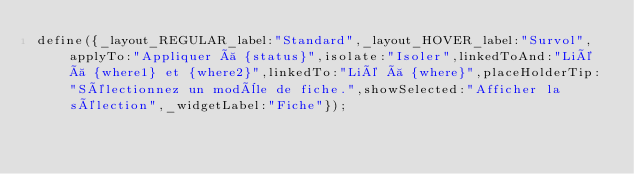<code> <loc_0><loc_0><loc_500><loc_500><_JavaScript_>define({_layout_REGULAR_label:"Standard",_layout_HOVER_label:"Survol",applyTo:"Appliquer à {status}",isolate:"Isoler",linkedToAnd:"Lié à {where1} et {where2}",linkedTo:"Lié à {where}",placeHolderTip:"Sélectionnez un modèle de fiche.",showSelected:"Afficher la sélection",_widgetLabel:"Fiche"});</code> 